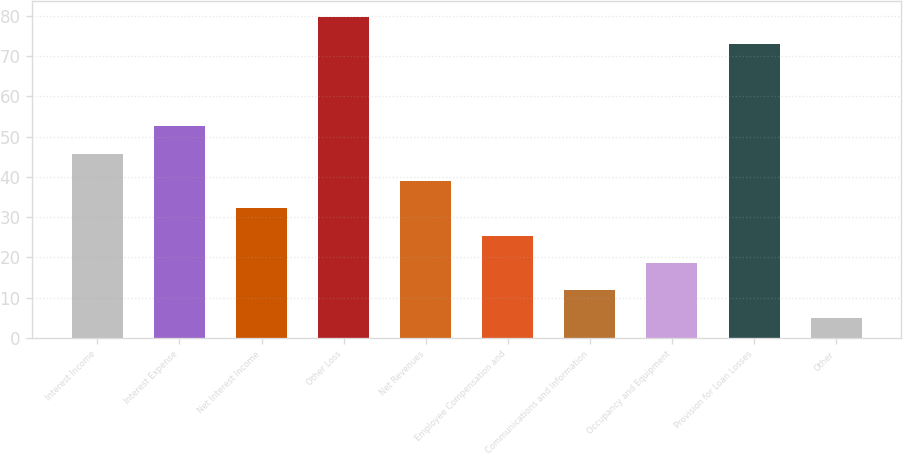Convert chart to OTSL. <chart><loc_0><loc_0><loc_500><loc_500><bar_chart><fcel>Interest Income<fcel>Interest Expense<fcel>Net Interest Income<fcel>Other Loss<fcel>Net Revenues<fcel>Employee Compensation and<fcel>Communications and Information<fcel>Occupancy and Equipment<fcel>Provision for Loan Losses<fcel>Other<nl><fcel>45.8<fcel>52.6<fcel>32.2<fcel>79.8<fcel>39<fcel>25.4<fcel>11.8<fcel>18.6<fcel>73<fcel>5<nl></chart> 